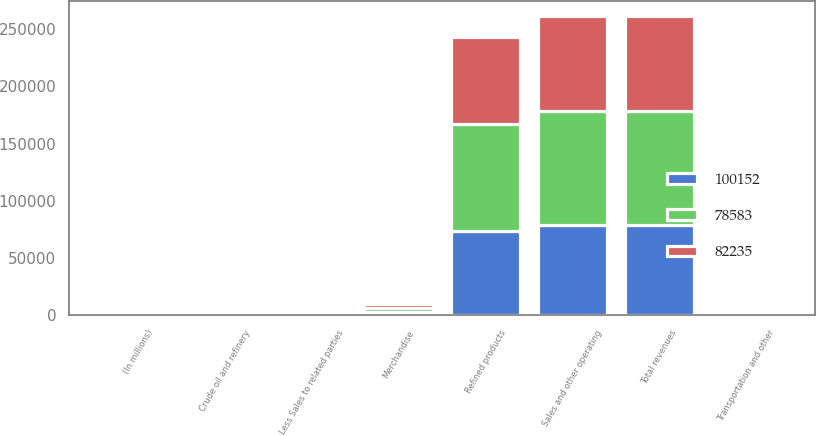Convert chart to OTSL. <chart><loc_0><loc_0><loc_500><loc_500><stacked_bar_chart><ecel><fcel>(In millions)<fcel>Refined products<fcel>Merchandise<fcel>Crude oil and refinery<fcel>Transportation and other<fcel>Total revenues<fcel>Less Sales to related parties<fcel>Sales and other operating<nl><fcel>78583<fcel>2013<fcel>93520<fcel>3308<fcel>2988<fcel>344<fcel>100160<fcel>8<fcel>100152<nl><fcel>82235<fcel>2012<fcel>76234<fcel>3229<fcel>2514<fcel>266<fcel>82243<fcel>8<fcel>82235<nl><fcel>100152<fcel>2011<fcel>73334<fcel>3090<fcel>1972<fcel>242<fcel>78638<fcel>55<fcel>78583<nl></chart> 